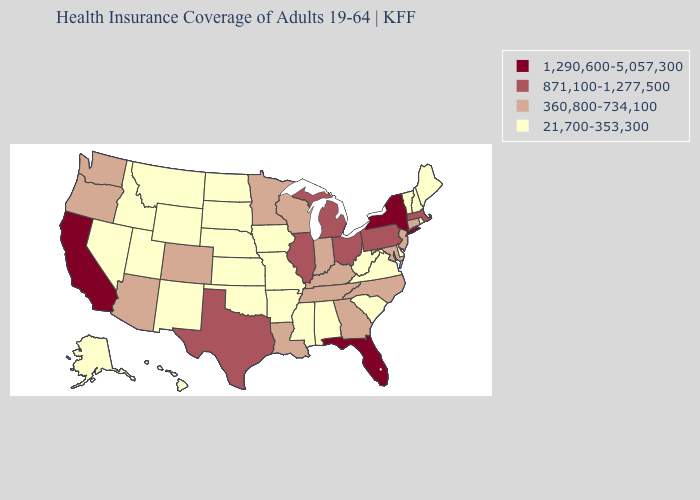Which states have the lowest value in the USA?
Give a very brief answer. Alabama, Alaska, Arkansas, Delaware, Hawaii, Idaho, Iowa, Kansas, Maine, Mississippi, Missouri, Montana, Nebraska, Nevada, New Hampshire, New Mexico, North Dakota, Oklahoma, Rhode Island, South Carolina, South Dakota, Utah, Vermont, Virginia, West Virginia, Wyoming. Does Arizona have the lowest value in the USA?
Give a very brief answer. No. Is the legend a continuous bar?
Concise answer only. No. Among the states that border Vermont , which have the lowest value?
Quick response, please. New Hampshire. What is the value of South Dakota?
Give a very brief answer. 21,700-353,300. Name the states that have a value in the range 360,800-734,100?
Short answer required. Arizona, Colorado, Connecticut, Georgia, Indiana, Kentucky, Louisiana, Maryland, Minnesota, New Jersey, North Carolina, Oregon, Tennessee, Washington, Wisconsin. How many symbols are there in the legend?
Be succinct. 4. What is the value of Wisconsin?
Concise answer only. 360,800-734,100. Does Arkansas have the highest value in the South?
Write a very short answer. No. Among the states that border West Virginia , which have the highest value?
Be succinct. Ohio, Pennsylvania. What is the lowest value in states that border South Dakota?
Be succinct. 21,700-353,300. Among the states that border Iowa , which have the lowest value?
Short answer required. Missouri, Nebraska, South Dakota. Does Kentucky have the lowest value in the USA?
Keep it brief. No. How many symbols are there in the legend?
Give a very brief answer. 4. What is the value of Michigan?
Quick response, please. 871,100-1,277,500. 